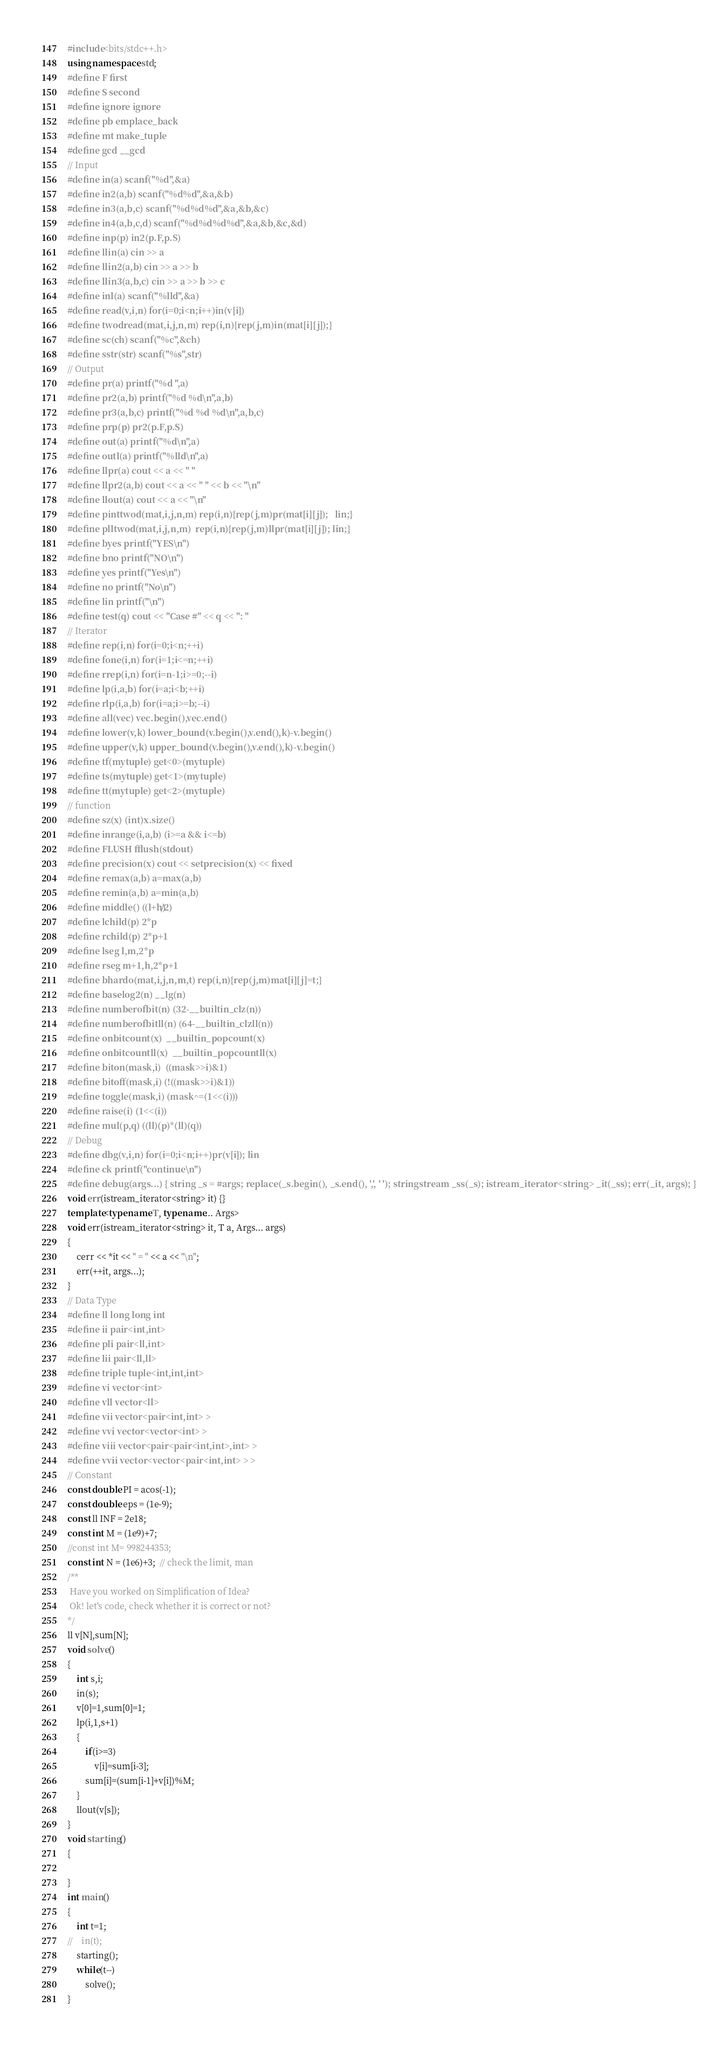<code> <loc_0><loc_0><loc_500><loc_500><_C++_>#include<bits/stdc++.h>
using namespace std;
#define F first
#define S second
#define ignore ignore
#define pb emplace_back
#define mt make_tuple
#define gcd __gcd
// Input
#define in(a) scanf("%d",&a)
#define in2(a,b) scanf("%d%d",&a,&b)
#define in3(a,b,c) scanf("%d%d%d",&a,&b,&c)
#define in4(a,b,c,d) scanf("%d%d%d%d",&a,&b,&c,&d)
#define inp(p) in2(p.F,p.S)
#define llin(a) cin >> a
#define llin2(a,b) cin >> a >> b
#define llin3(a,b,c) cin >> a >> b >> c
#define inl(a) scanf("%lld",&a)
#define read(v,i,n) for(i=0;i<n;i++)in(v[i])
#define twodread(mat,i,j,n,m) rep(i,n){rep(j,m)in(mat[i][j]);}
#define sc(ch) scanf("%c",&ch)
#define sstr(str) scanf("%s",str)
// Output
#define pr(a) printf("%d ",a)
#define pr2(a,b) printf("%d %d\n",a,b)
#define pr3(a,b,c) printf("%d %d %d\n",a,b,c)
#define prp(p) pr2(p.F,p.S)
#define out(a) printf("%d\n",a)
#define outl(a) printf("%lld\n",a)
#define llpr(a) cout << a << " "
#define llpr2(a,b) cout << a << " " << b << "\n"
#define llout(a) cout << a << "\n"
#define pinttwod(mat,i,j,n,m) rep(i,n){rep(j,m)pr(mat[i][j]);   lin;}
#define plltwod(mat,i,j,n,m)  rep(i,n){rep(j,m)llpr(mat[i][j]); lin;}
#define byes printf("YES\n")
#define bno printf("NO\n")
#define yes printf("Yes\n")
#define no printf("No\n")
#define lin printf("\n")
#define test(q) cout << "Case #" << q << ": "
// Iterator
#define rep(i,n) for(i=0;i<n;++i)
#define fone(i,n) for(i=1;i<=n;++i)
#define rrep(i,n) for(i=n-1;i>=0;--i)
#define lp(i,a,b) for(i=a;i<b;++i)
#define rlp(i,a,b) for(i=a;i>=b;--i)
#define all(vec) vec.begin(),vec.end()
#define lower(v,k) lower_bound(v.begin(),v.end(),k)-v.begin()
#define upper(v,k) upper_bound(v.begin(),v.end(),k)-v.begin()
#define tf(mytuple) get<0>(mytuple)
#define ts(mytuple) get<1>(mytuple)
#define tt(mytuple) get<2>(mytuple)
// function
#define sz(x) (int)x.size()
#define inrange(i,a,b) (i>=a && i<=b)
#define FLUSH fflush(stdout)
#define precision(x) cout << setprecision(x) << fixed
#define remax(a,b) a=max(a,b)
#define remin(a,b) a=min(a,b)
#define middle() ((l+h)/2)
#define lchild(p) 2*p
#define rchild(p) 2*p+1
#define lseg l,m,2*p
#define rseg m+1,h,2*p+1
#define bhardo(mat,i,j,n,m,t) rep(i,n){rep(j,m)mat[i][j]=t;}
#define baselog2(n) __lg(n)
#define numberofbit(n) (32-__builtin_clz(n))
#define numberofbitll(n) (64-__builtin_clzll(n))
#define onbitcount(x)  __builtin_popcount(x)
#define onbitcountll(x)  __builtin_popcountll(x)
#define biton(mask,i)  ((mask>>i)&1)
#define bitoff(mask,i) (!((mask>>i)&1))
#define toggle(mask,i) (mask^=(1<<(i)))
#define raise(i) (1<<(i))
#define mul(p,q) ((ll)(p)*(ll)(q))
// Debug
#define dbg(v,i,n) for(i=0;i<n;i++)pr(v[i]); lin
#define ck printf("continue\n")
#define debug(args...) { string _s = #args; replace(_s.begin(), _s.end(), ',', ' '); stringstream _ss(_s); istream_iterator<string> _it(_ss); err(_it, args); }
void err(istream_iterator<string> it) {}
template<typename T, typename... Args>
void err(istream_iterator<string> it, T a, Args... args)
{
	cerr << *it << " = " << a << "\n";
	err(++it, args...);
}
// Data Type
#define ll long long int
#define ii pair<int,int>
#define pli pair<ll,int>
#define lii pair<ll,ll>
#define triple tuple<int,int,int>
#define vi vector<int>
#define vll vector<ll>
#define vii vector<pair<int,int> >
#define vvi vector<vector<int> >
#define viii vector<pair<pair<int,int>,int> >
#define vvii vector<vector<pair<int,int> > >
// Constant
const double PI = acos(-1);
const double eps = (1e-9);
const ll INF = 2e18;
const int M = (1e9)+7;
//const int M= 998244353;
const int N = (1e6)+3;  // check the limit, man
/**
 Have you worked on Simplification of Idea?
 Ok! let's code, check whether it is correct or not?
*/
ll v[N],sum[N];
void solve()
{
    int s,i;
    in(s);
    v[0]=1,sum[0]=1;
    lp(i,1,s+1)
    {
        if(i>=3)
            v[i]=sum[i-3];
        sum[i]=(sum[i-1]+v[i])%M;
    }
    llout(v[s]);
}
void starting()
{

}
int main()
{
    int t=1;
//    in(t);
    starting();
    while(t--)
        solve();
}






</code> 